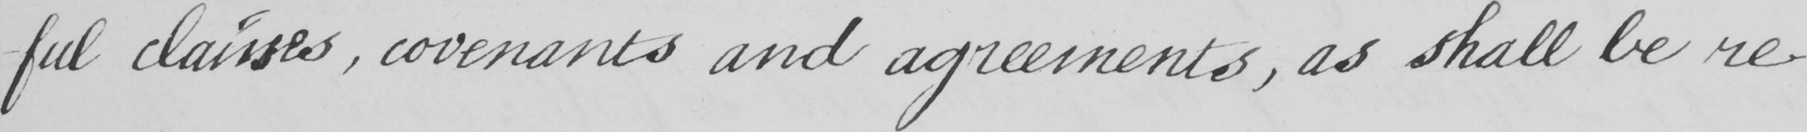What is written in this line of handwriting? -ful clauses, covenants and agreements, as shall be re- 